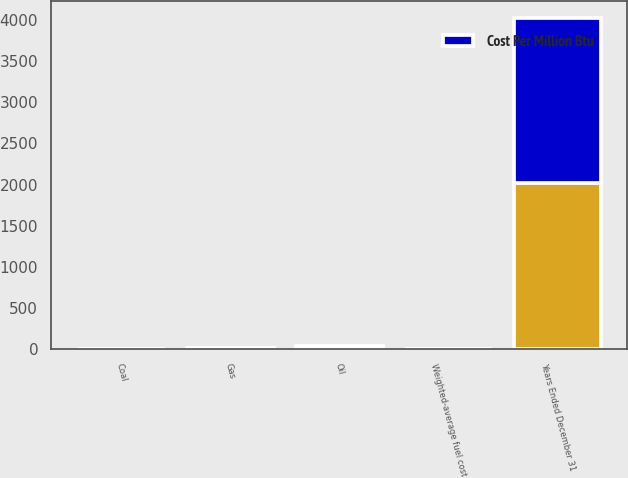<chart> <loc_0><loc_0><loc_500><loc_500><stacked_bar_chart><ecel><fcel>Years Ended December 31<fcel>Coal<fcel>Gas<fcel>Oil<fcel>Weighted-average fuel cost<nl><fcel>nan<fcel>2014<fcel>2.72<fcel>7.19<fcel>20.16<fcel>3.17<nl><fcel>Cost Per Million Btu<fcel>2011<fcel>2.94<fcel>4.95<fcel>18.55<fcel>3.18<nl></chart> 